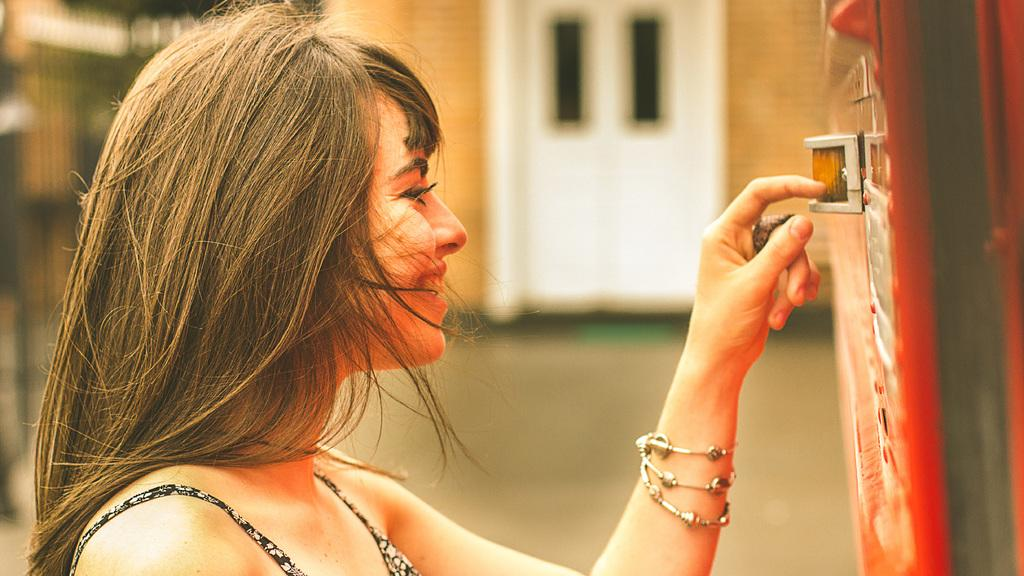Who is present in the image? There is a lady in the image. What can be seen on the right side of the image? There is an object on the right side of the image. What is visible in the background of the image? There is a wall with doors in the background of the image. How would you describe the background of the image? The background is blurry. What type of tax is being discussed in the image? There is no mention or indication of any tax-related discussion in the image. 